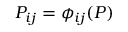<formula> <loc_0><loc_0><loc_500><loc_500>P _ { i j } = \phi _ { i j } ( P )</formula> 